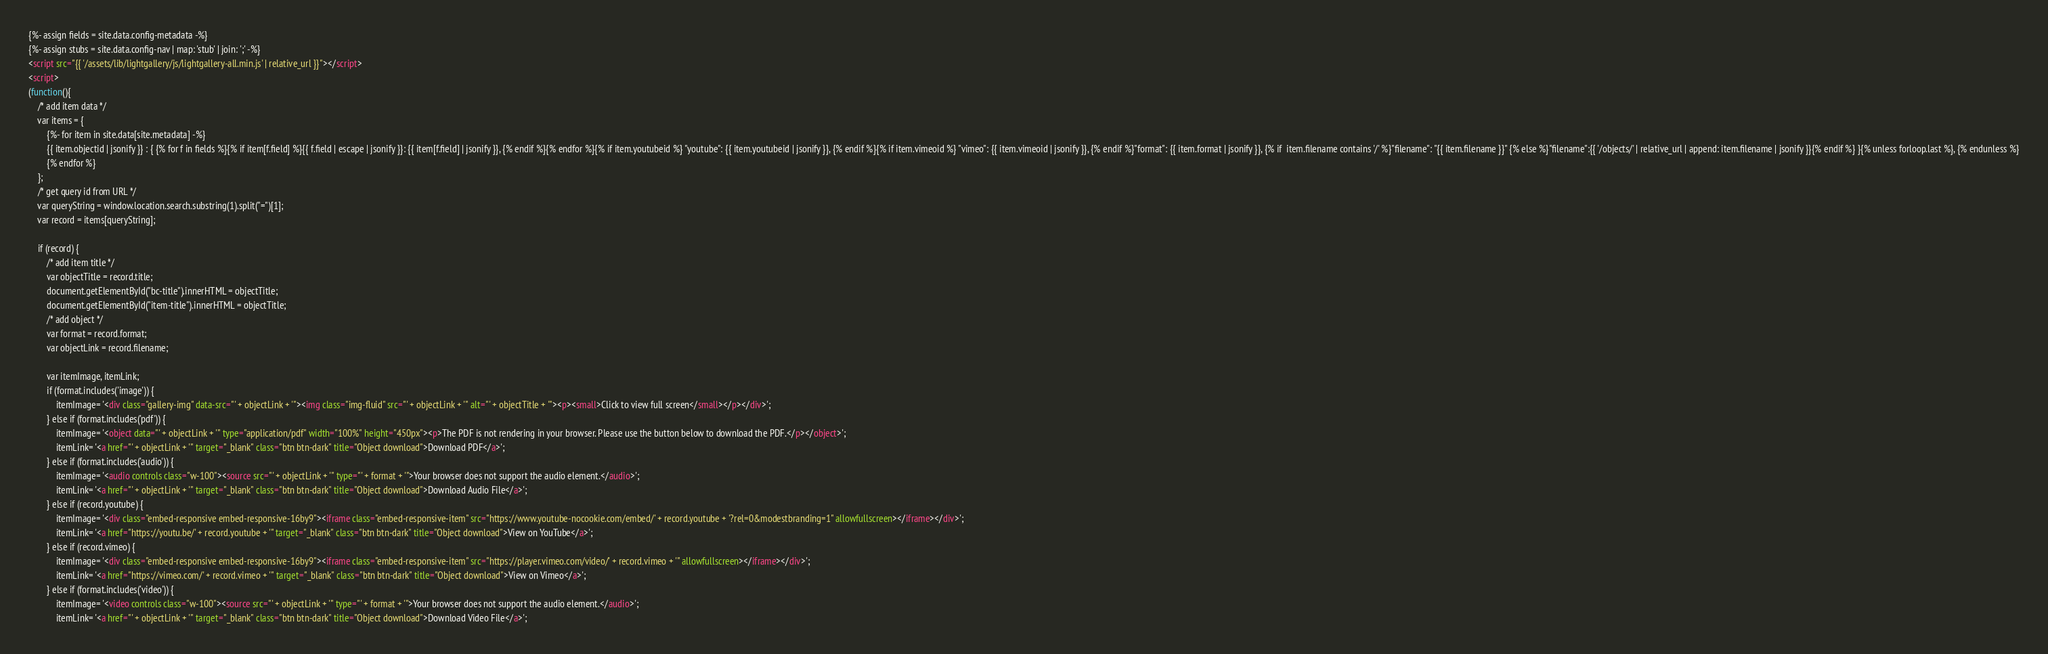Convert code to text. <code><loc_0><loc_0><loc_500><loc_500><_HTML_>{%- assign fields = site.data.config-metadata -%}
{%- assign stubs = site.data.config-nav | map: 'stub' | join: ';' -%}
<script src="{{ '/assets/lib/lightgallery/js/lightgallery-all.min.js' | relative_url }}"></script>
<script>
(function(){
    /* add item data */
    var items = { 
        {%- for item in site.data[site.metadata] -%}
        {{ item.objectid | jsonify }} : { {% for f in fields %}{% if item[f.field] %}{{ f.field | escape | jsonify }}: {{ item[f.field] | jsonify }}, {% endif %}{% endfor %}{% if item.youtubeid %} "youtube": {{ item.youtubeid | jsonify }}, {% endif %}{% if item.vimeoid %} "vimeo": {{ item.vimeoid | jsonify }}, {% endif %}"format": {{ item.format | jsonify }}, {% if  item.filename contains '/' %}"filename": "{{ item.filename }}" {% else %}"filename":{{ '/objects/' | relative_url | append: item.filename | jsonify }}{% endif %} }{% unless forloop.last %}, {% endunless %}
        {% endfor %}
    };
    /* get query id from URL */
    var queryString = window.location.search.substring(1).split("=")[1];
    var record = items[queryString];

    if (record) {
        /* add item title */
        var objectTitle = record.title;
        document.getElementById("bc-title").innerHTML = objectTitle;
        document.getElementById("item-title").innerHTML = objectTitle;
        /* add object */ 
        var format = record.format;
        var objectLink = record.filename;

        var itemImage, itemLink;
        if (format.includes('image')) {
            itemImage= '<div class="gallery-img" data-src="' + objectLink + '"><img class="img-fluid" src="' + objectLink + '" alt="' + objectTitle + '"><p><small>Click to view full screen</small></p></div>';
        } else if (format.includes('pdf')) {
            itemImage= '<object data="' + objectLink + '" type="application/pdf" width="100%" height="450px"><p>The PDF is not rendering in your browser. Please use the button below to download the PDF.</p></object>';
            itemLink= '<a href="' + objectLink + '" target="_blank" class="btn btn-dark" title="Object download">Download PDF</a>';
        } else if (format.includes('audio')) {
            itemImage= '<audio controls class="w-100"><source src="' + objectLink + '" type="' + format + '">Your browser does not support the audio element.</audio>';
            itemLink= '<a href="' + objectLink + '" target="_blank" class="btn btn-dark" title="Object download">Download Audio File</a>';
        } else if (record.youtube) {
            itemImage= '<div class="embed-responsive embed-responsive-16by9"><iframe class="embed-responsive-item" src="https://www.youtube-nocookie.com/embed/' + record.youtube + '?rel=0&modestbranding=1" allowfullscreen></iframe></div>';
            itemLink= '<a href="https://youtu.be/' + record.youtube + '" target="_blank" class="btn btn-dark" title="Object download">View on YouTube</a>';
        } else if (record.vimeo) {
            itemImage= '<div class="embed-responsive embed-responsive-16by9"><iframe class="embed-responsive-item" src="https://player.vimeo.com/video/' + record.vimeo + '" allowfullscreen></iframe></div>';
            itemLink= '<a href="https://vimeo.com/' + record.vimeo + '" target="_blank" class="btn btn-dark" title="Object download">View on Vimeo</a>';
        } else if (format.includes('video')) {
            itemImage= '<video controls class="w-100"><source src="' + objectLink + '" type="' + format + '">Your browser does not support the audio element.</audio>';
            itemLink= '<a href="' + objectLink + '" target="_blank" class="btn btn-dark" title="Object download">Download Video File</a>';</code> 